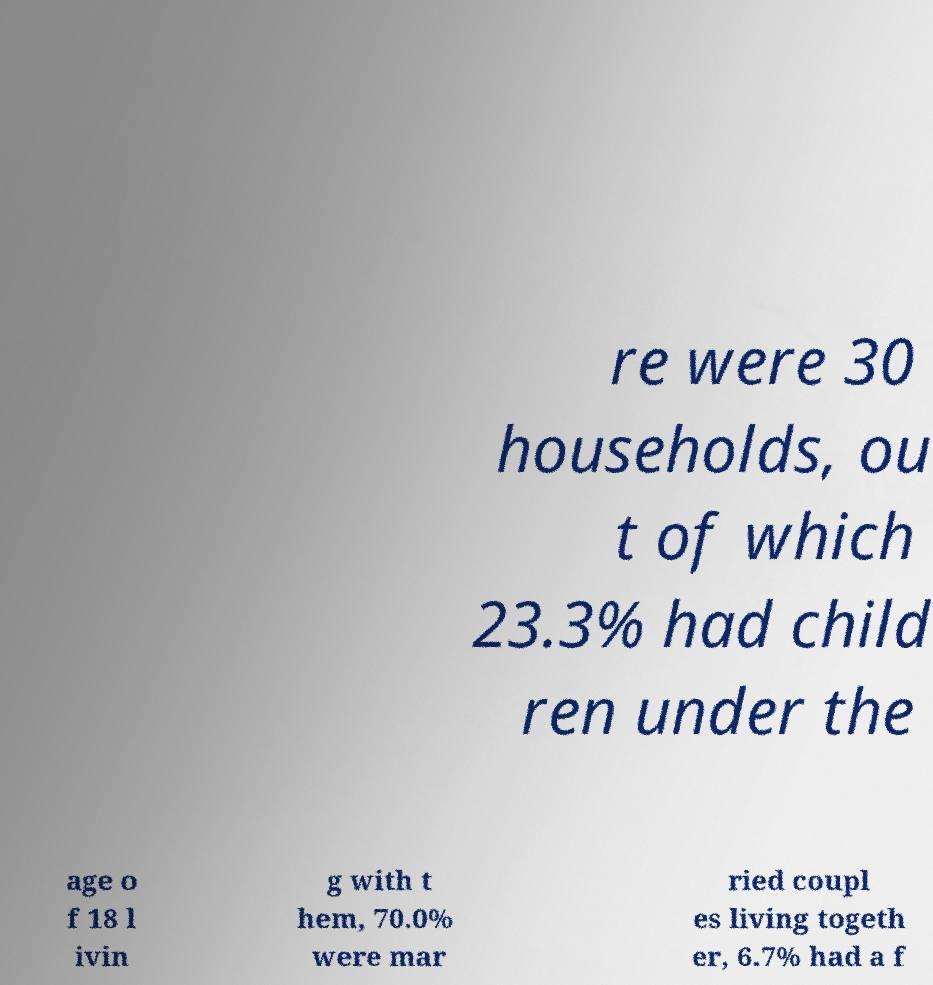Could you extract and type out the text from this image? re were 30 households, ou t of which 23.3% had child ren under the age o f 18 l ivin g with t hem, 70.0% were mar ried coupl es living togeth er, 6.7% had a f 